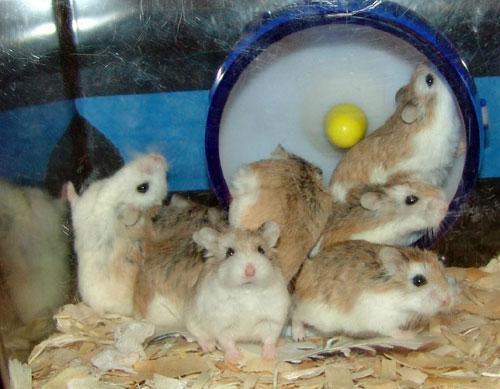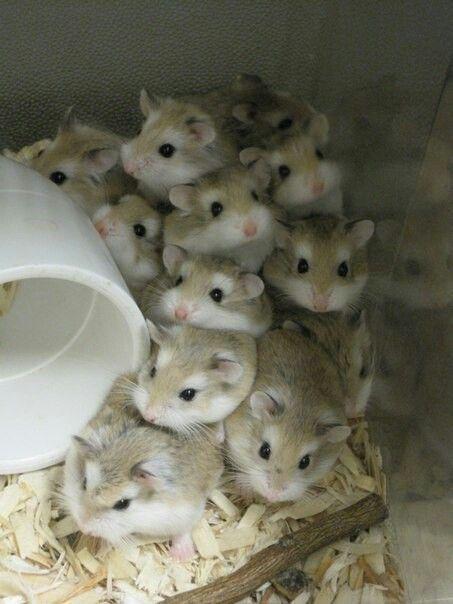The first image is the image on the left, the second image is the image on the right. Considering the images on both sides, is "One of the images shows hamsters crowded inside a container that has ears on top of it." valid? Answer yes or no. No. 